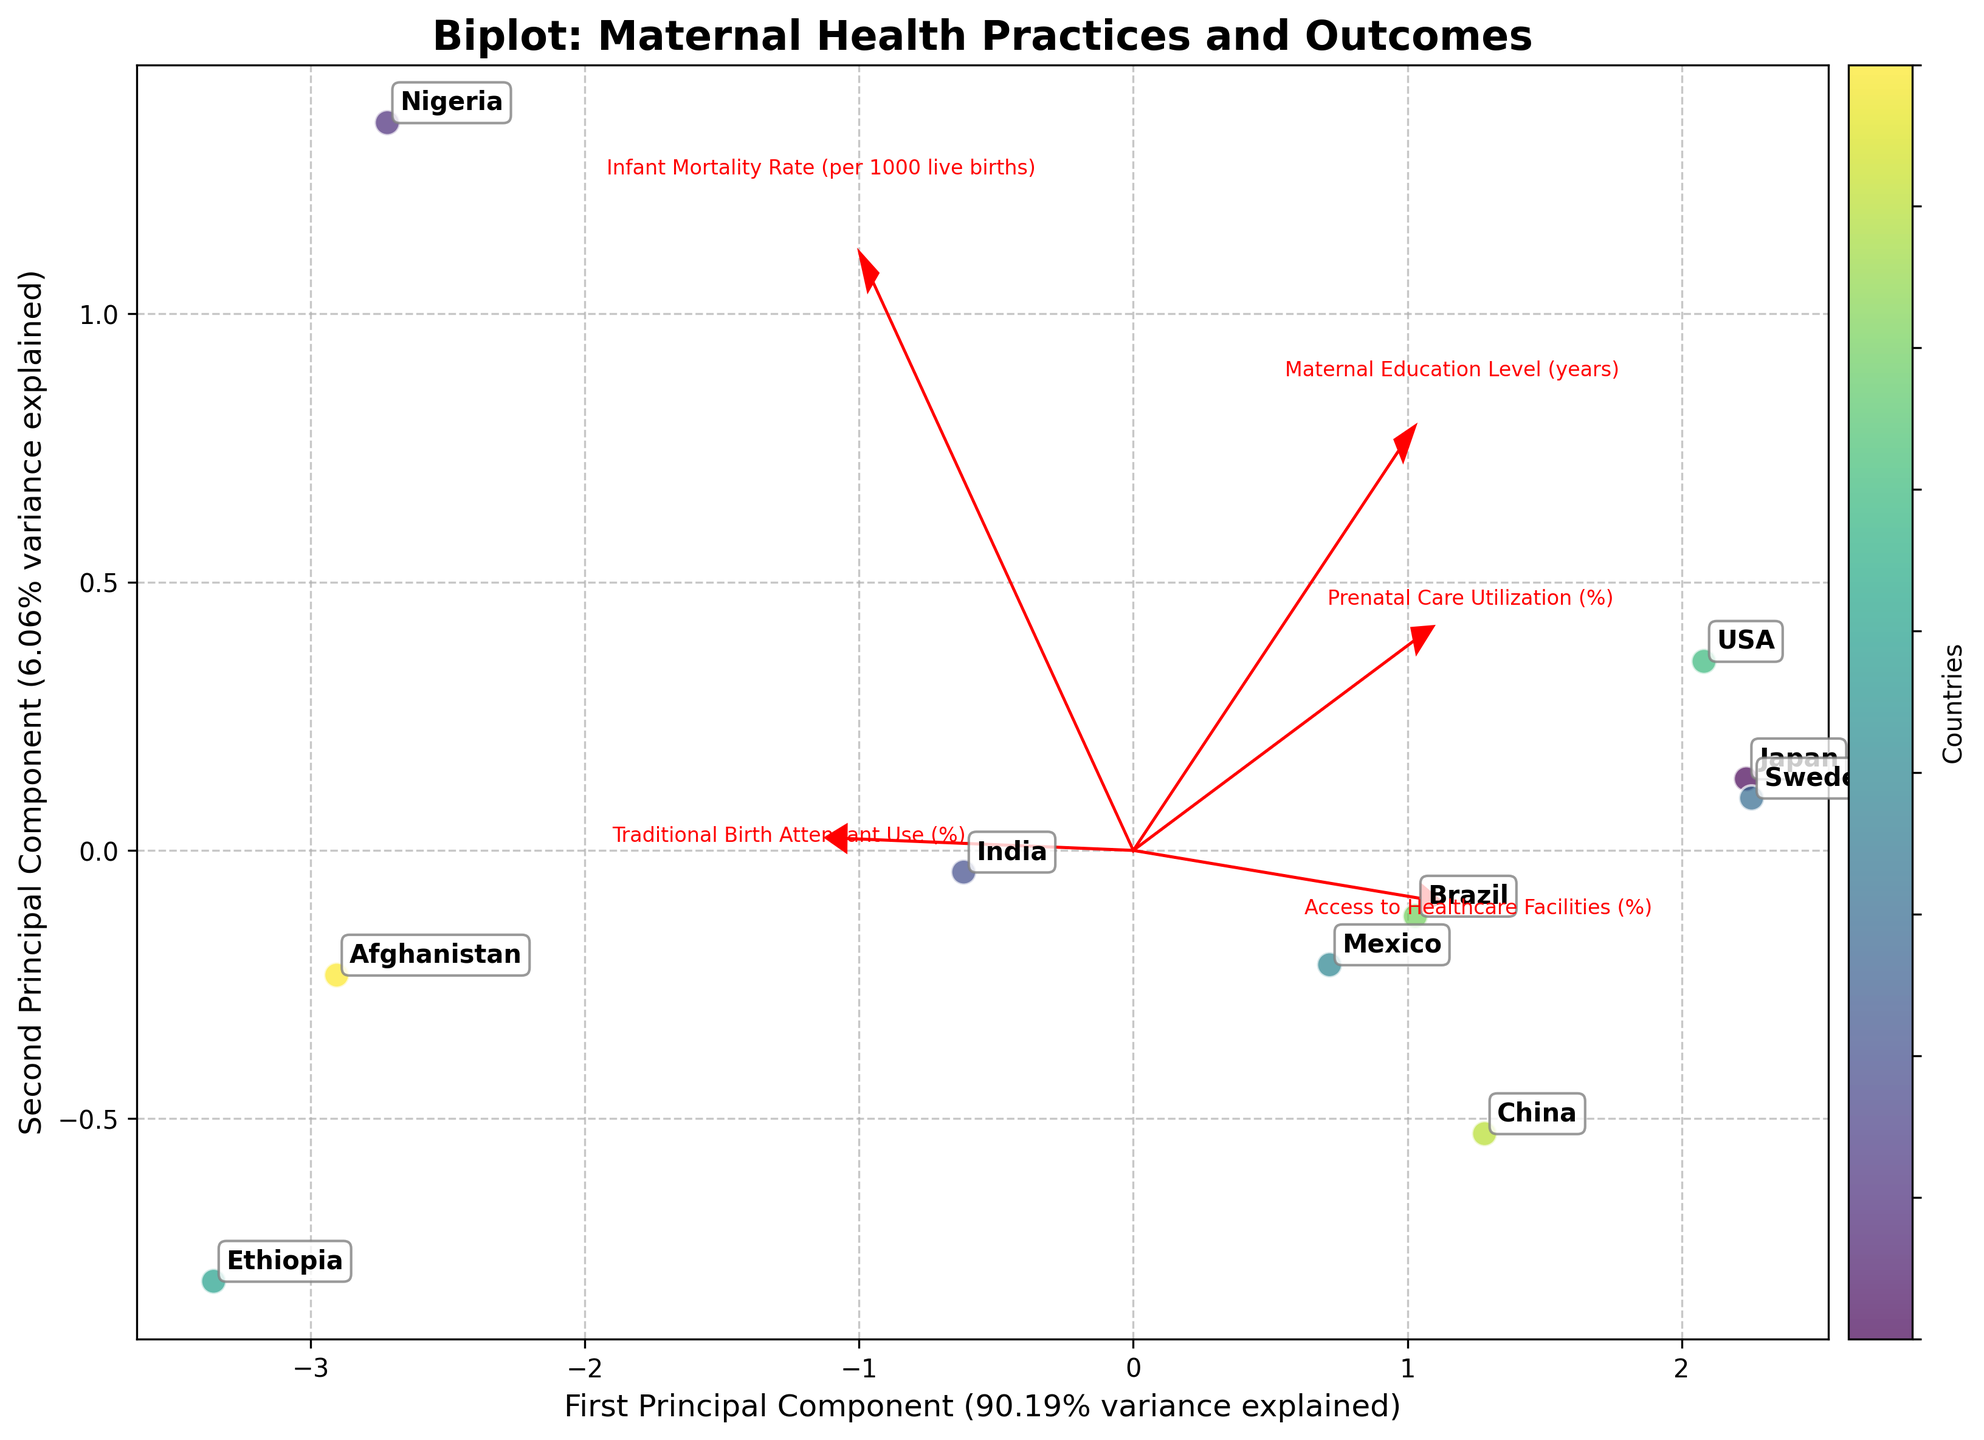How many principal components are presented in the biplot? The biplot shows two principal components as indicated by the labels on the x and y axes.
Answer: Two What is the title of the biplot? The title of the biplot is located at the top of the figure. It reads "Biplot: Maternal Health Practices and Outcomes."
Answer: Biplot: Maternal Health Practices and Outcomes Which country is positioned closest to the origin of the plot? By observing the position of various countries relative to the origin (0,0), it appears that China is the closest to the origin.
Answer: China Which principal component explains more variance in the data? The biplot's x-axis label shows the percentage of variance explained by the first principal component, and the y-axis label shows the second. The first principal component explains more variance as indicated by its higher percentage value.
Answer: The first principal component Which country lies the farthest to the right on the first principal component? The position of countries along the first principal component axis (x-axis) shows that Mexico is the farthest to the right.
Answer: Mexico Between Nigeria and Ethiopia, which country has a higher infant mortality rate based on the biplot positioning? The direction and length of the "Infant Mortality Rate" vector indicate higher values. Ethiopia lies closer to this vector's direction than Nigeria, indicating a higher infant mortality rate.
Answer: Ethiopia Which feature vector lies closest to the direction of traditional birth attendant use (%)? The biplot includes vectors for various features. The vector labeled "Traditional Birth Attendant Use (%)" points in a particular direction, indicating the highest inclination. Nigeria and Ethiopia are closest to this direction.
Answer: Traditional Birth Attendant Use (%) Are the USA and Sweden similarly positioned in terms of maternal health practices and outcomes? Considering their proximity in the biplot (i.e., their principal component scores), the USA and Sweden are positioned relatively close to each other, indicating similar maternal health practices and outcomes.
Answer: Yes What is the general trend observed for countries with higher access to healthcare facilities (%) in the biplot? The vector for "Access to Healthcare Facilities (%)" points toward a particular direction. Countries like Sweden, Japan, and the USA, which are in that direction, generally have higher healthcare access.
Answer: Higher access to healthcare facilities Based on the biplot, which country seems to have an inverse relationship between prenatal care utilization and traditional birth attendant use? Nigeria lies far from the vector for "Prenatal Care Utilization (%)" but closer to the vector for "Traditional Birth Attendant Use (%)," indicating an inverse relationship.
Answer: Nigeria 